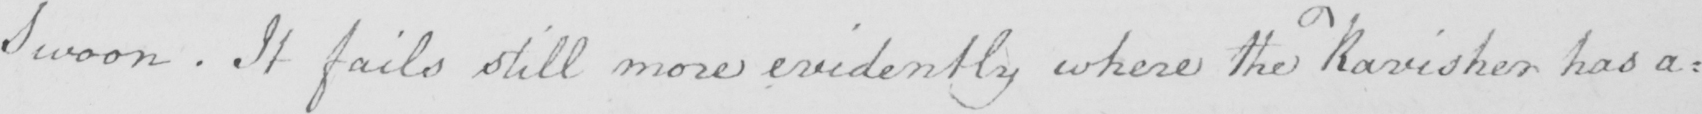What text is written in this handwritten line? Swoon . It fails still more evidently where the Ravisher has a : 